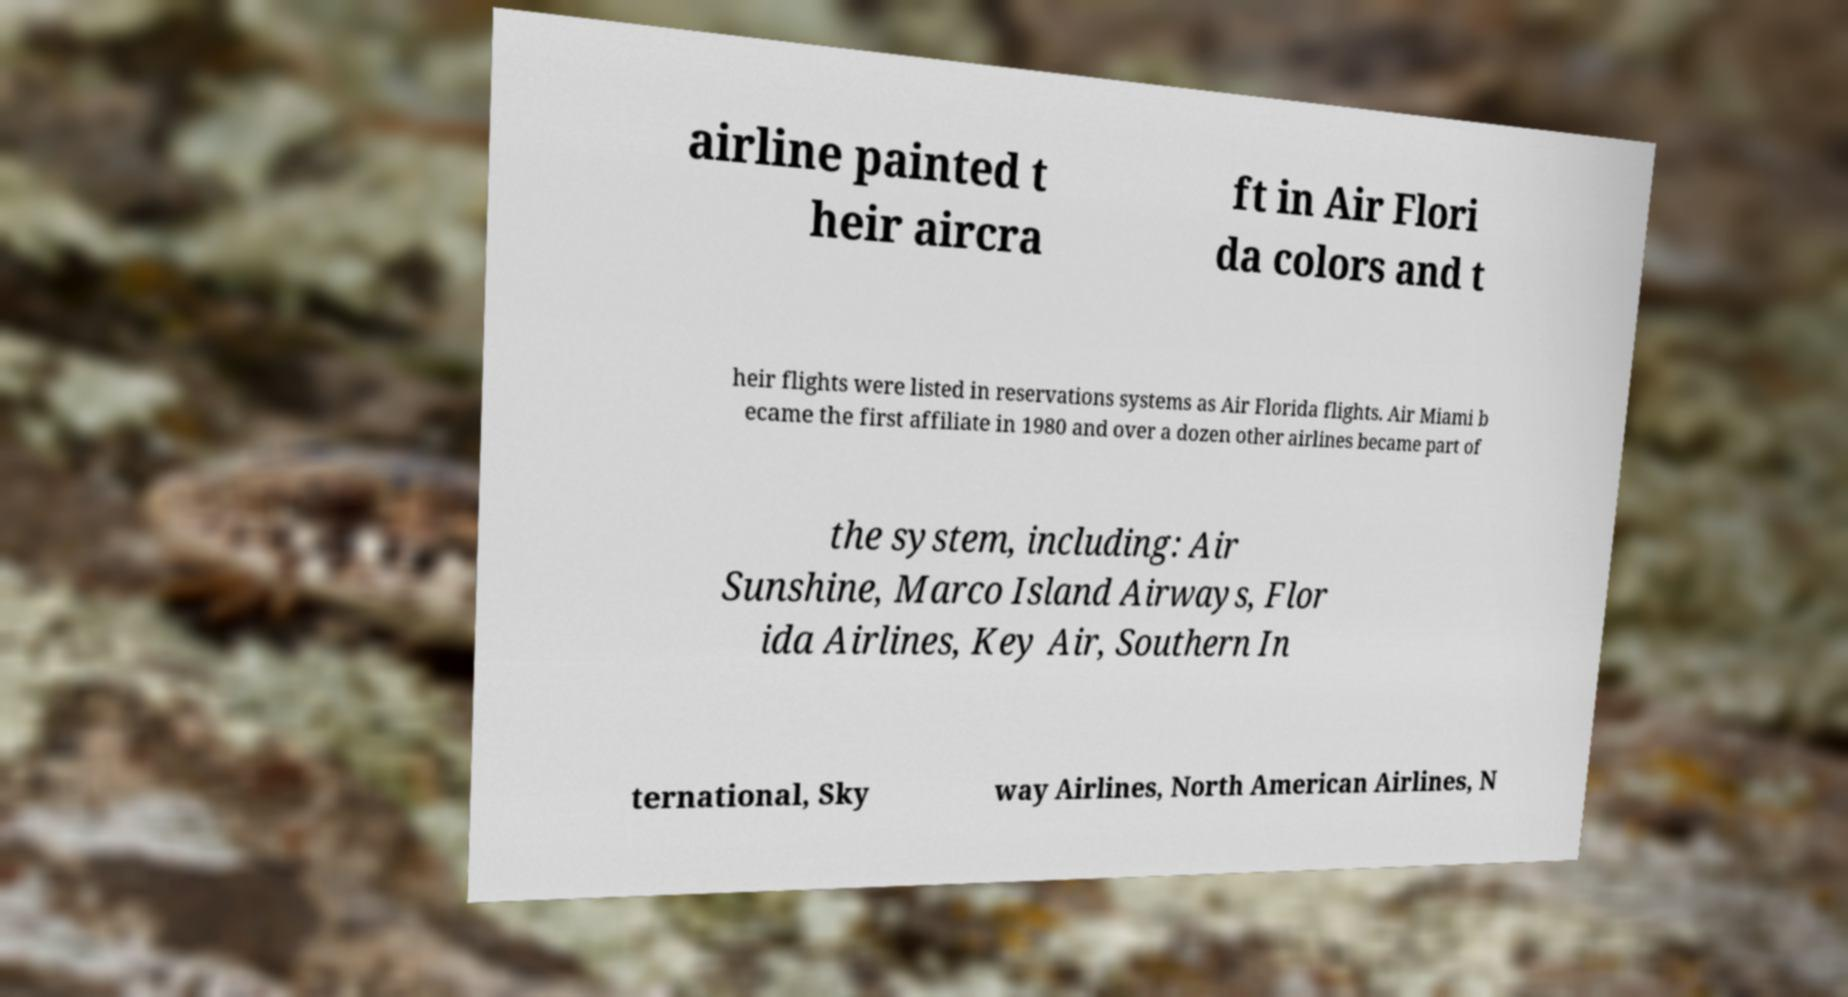Please read and relay the text visible in this image. What does it say? airline painted t heir aircra ft in Air Flori da colors and t heir flights were listed in reservations systems as Air Florida flights. Air Miami b ecame the first affiliate in 1980 and over a dozen other airlines became part of the system, including: Air Sunshine, Marco Island Airways, Flor ida Airlines, Key Air, Southern In ternational, Sky way Airlines, North American Airlines, N 